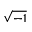Convert formula to latex. <formula><loc_0><loc_0><loc_500><loc_500>\sqrt { - 1 }</formula> 